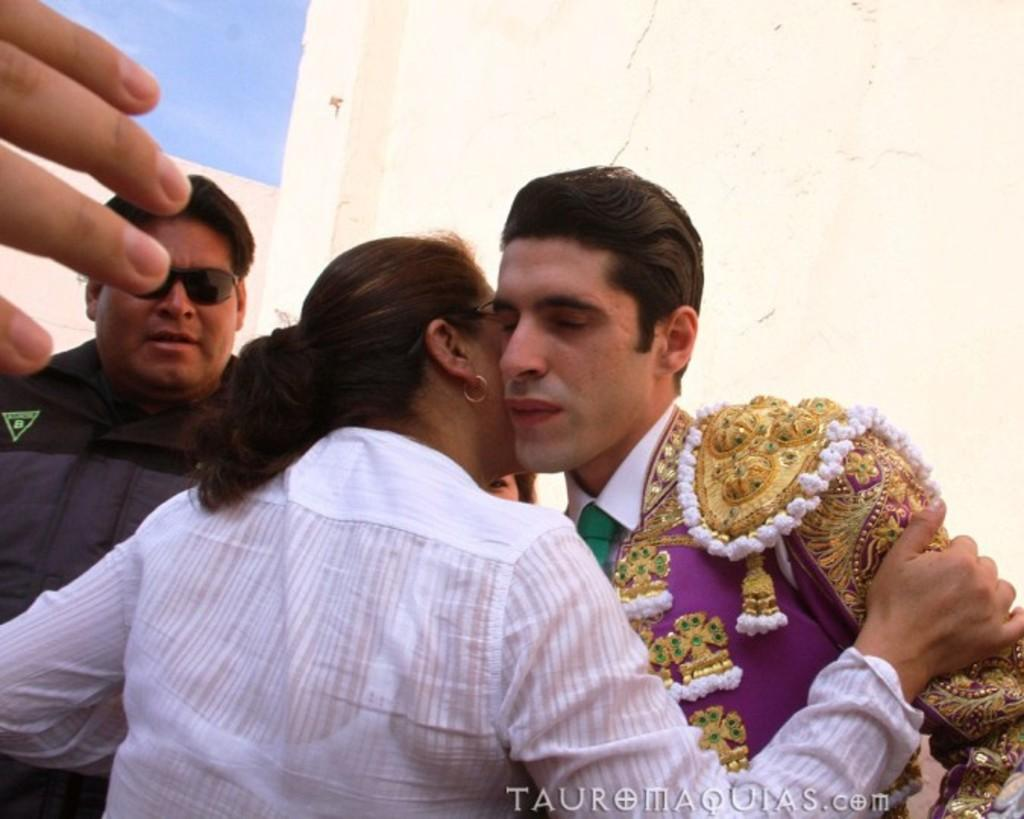How many people are in the image? There is a group of people in the image. What can be observed about the clothing of the people in the image? The people are wearing different color dresses. Can you describe any specific accessory worn by one of the people? One person is wearing goggles. What is visible in the background of the image? There is a wall and the sky in the background of the image. What color is the sky in the image? The sky is blue in the background of the image. What type of crops are the farmers protesting against in the image? There are no farmers or protest present in the image. How is the measurement of the distance between the objects in the image being conducted? There is no measurement being conducted in the image. 